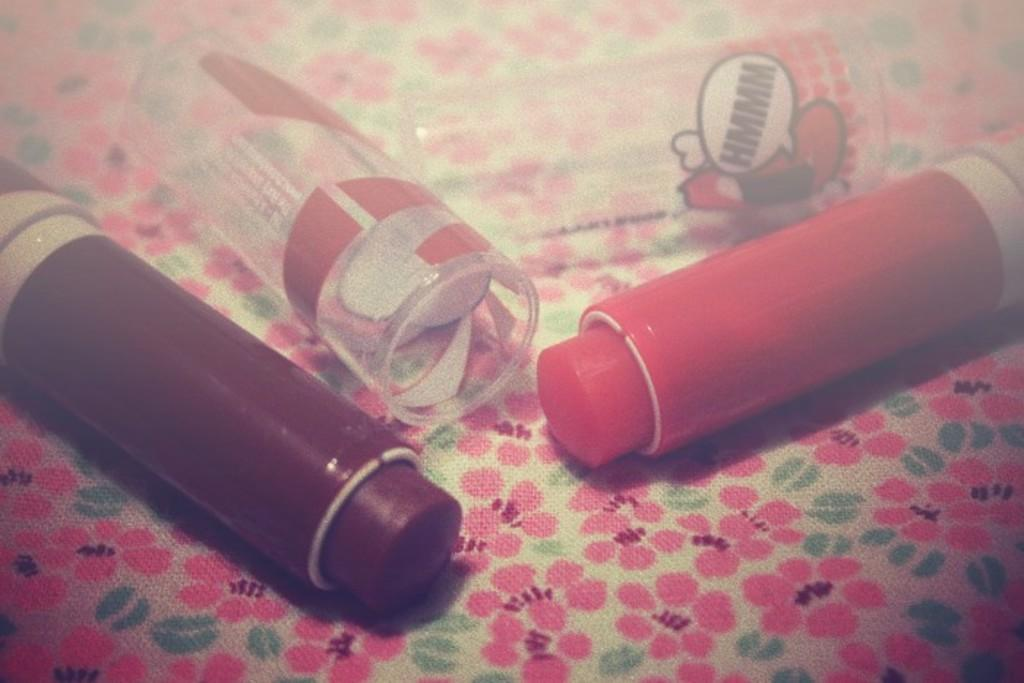What type of cosmetic product can be seen in the image? There are lipsticks in the image. Where are the lipsticks located? The lipsticks are placed on a table. What type of knife is being used to trim the bushes in the image? There are no knives or bushes present in the image; it only features lipsticks placed on a table. 